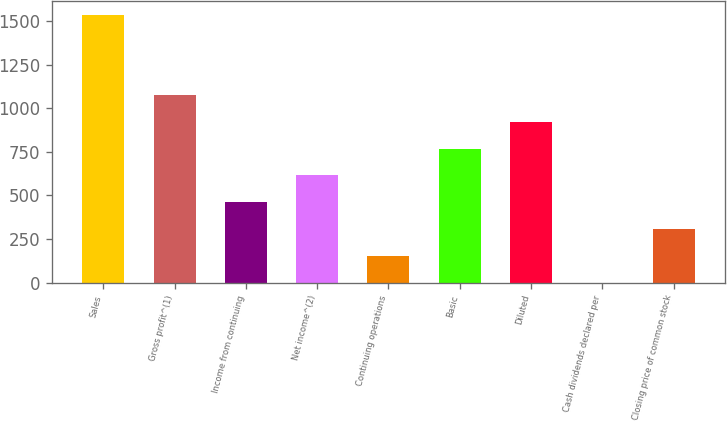Convert chart. <chart><loc_0><loc_0><loc_500><loc_500><bar_chart><fcel>Sales<fcel>Gross profit^(1)<fcel>Income from continuing<fcel>Net income^(2)<fcel>Continuing operations<fcel>Basic<fcel>Diluted<fcel>Cash dividends declared per<fcel>Closing price of common stock<nl><fcel>1536<fcel>1075.23<fcel>460.87<fcel>614.46<fcel>153.69<fcel>768.05<fcel>921.64<fcel>0.1<fcel>307.28<nl></chart> 